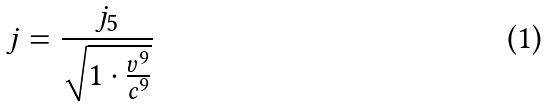<formula> <loc_0><loc_0><loc_500><loc_500>j = \frac { j _ { 5 } } { \sqrt { 1 \cdot \frac { v ^ { 9 } } { c ^ { 9 } } } }</formula> 